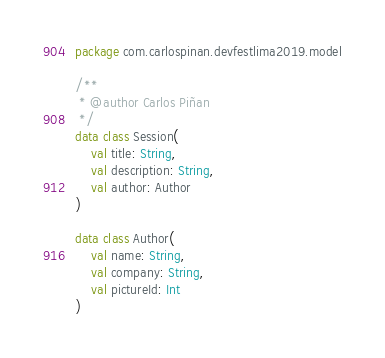Convert code to text. <code><loc_0><loc_0><loc_500><loc_500><_Kotlin_>package com.carlospinan.devfestlima2019.model

/**
 * @author Carlos Piñan
 */
data class Session(
    val title: String,
    val description: String,
    val author: Author
)

data class Author(
    val name: String,
    val company: String,
    val pictureId: Int
)</code> 